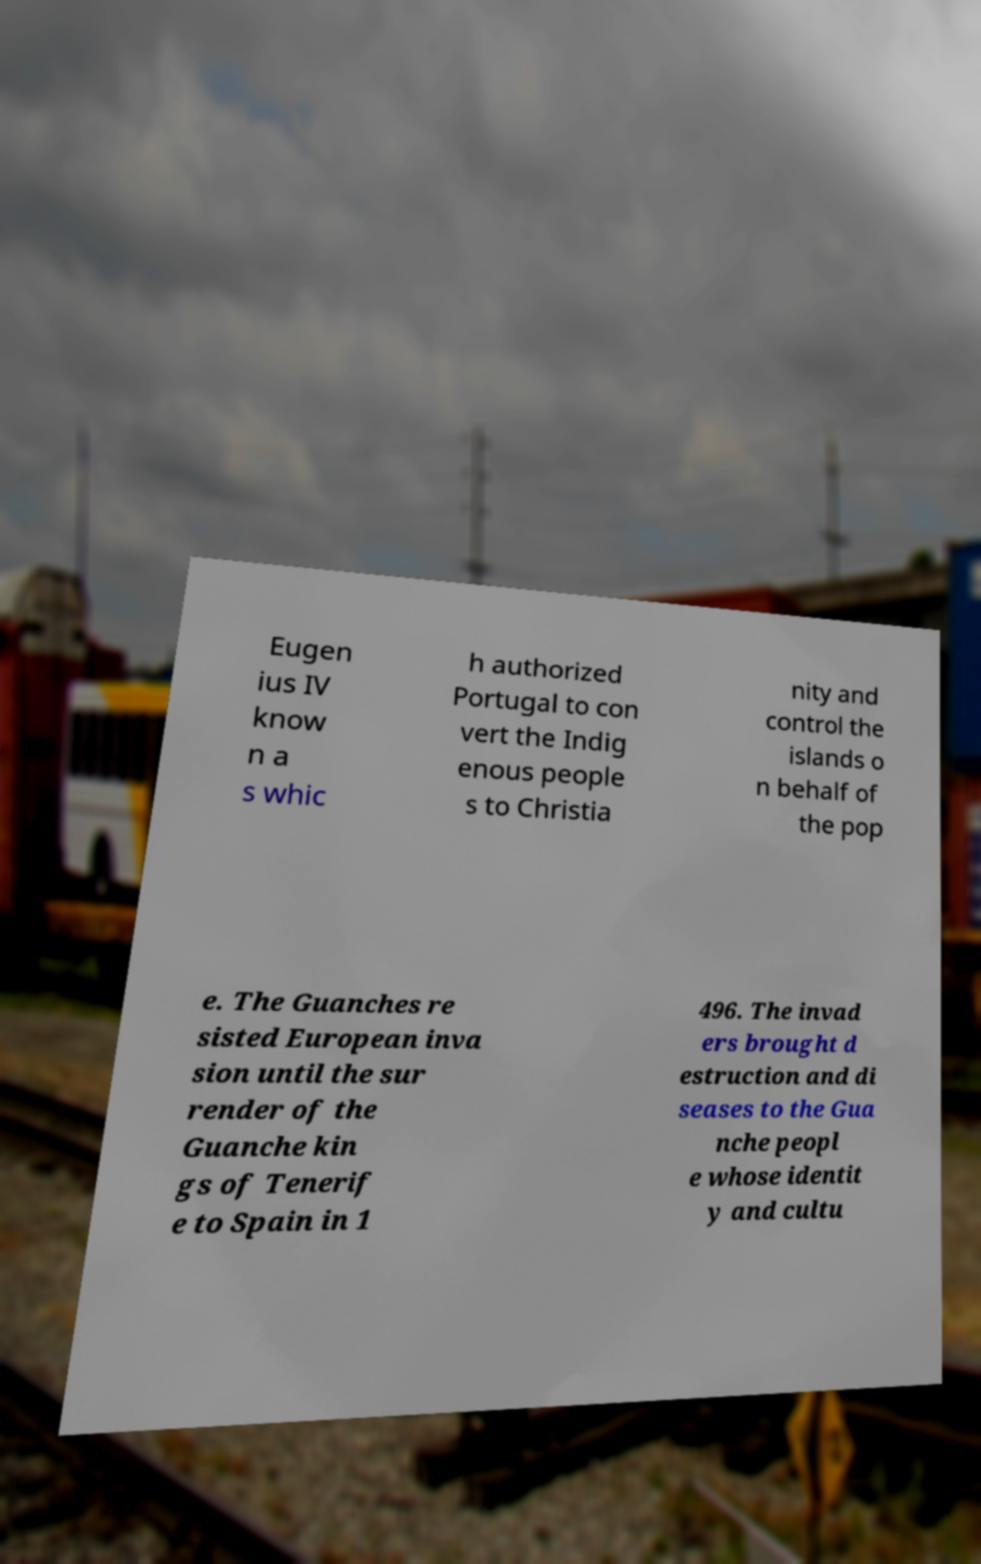Could you assist in decoding the text presented in this image and type it out clearly? Eugen ius IV know n a s whic h authorized Portugal to con vert the Indig enous people s to Christia nity and control the islands o n behalf of the pop e. The Guanches re sisted European inva sion until the sur render of the Guanche kin gs of Tenerif e to Spain in 1 496. The invad ers brought d estruction and di seases to the Gua nche peopl e whose identit y and cultu 